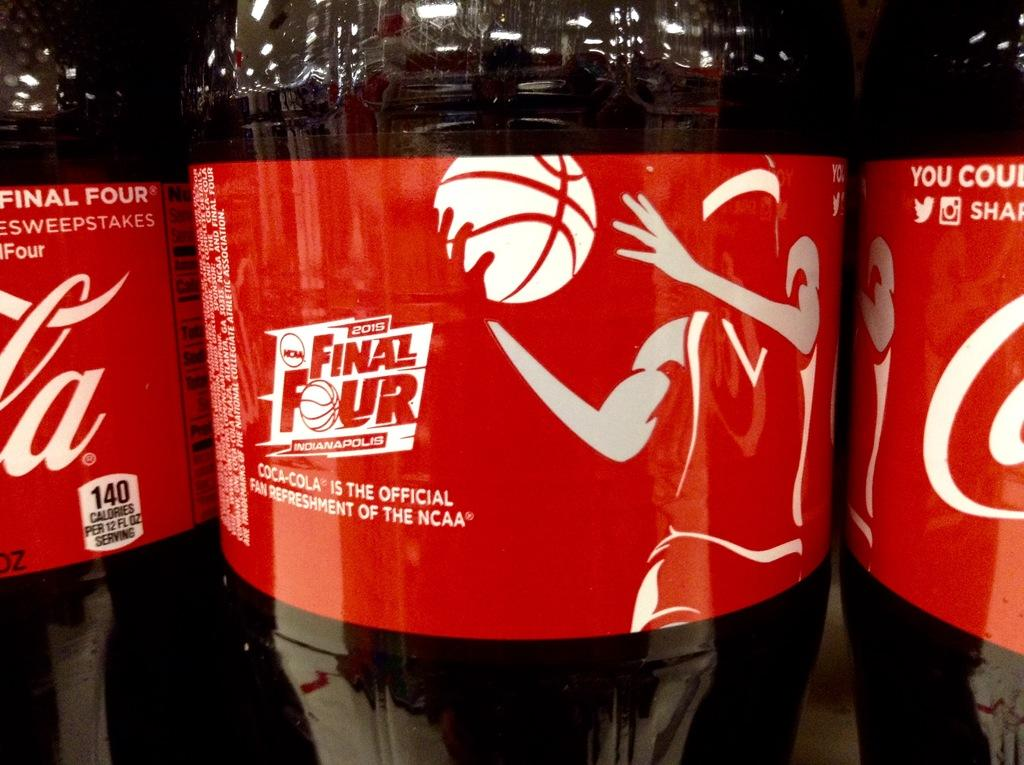How many bottles are visible in the image? There are three bottles in the image. What brand of drink do the bottles contain? The bottles contain Coca-Cola, as indicated by the stickers on them. What is depicted on the stickers of the bottles? The stickers on the bottles depict a person holding a ball. What is inside the bottles? The bottles contain drinks. How does the pig contribute to the washing of the bottles in the image? There is no pig present in the image, and therefore no such activity can be observed. 